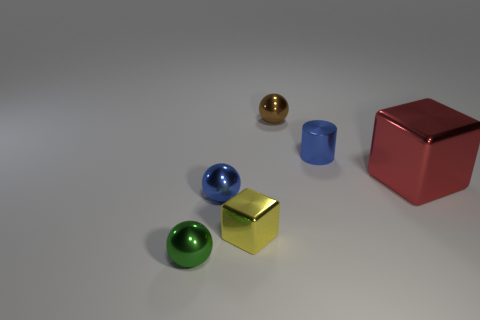Is there anything else that is the same size as the red block?
Offer a very short reply. No. There is a small green thing that is the same shape as the tiny brown object; what material is it?
Provide a succinct answer. Metal. What number of things are green things or gray cylinders?
Your answer should be compact. 1. What number of brown things are the same shape as the green thing?
Offer a terse response. 1. Is the material of the big red object the same as the blue thing that is behind the red metal block?
Offer a terse response. Yes. What size is the red cube that is made of the same material as the tiny yellow object?
Provide a succinct answer. Large. There is a blue cylinder right of the brown ball; what size is it?
Your answer should be very brief. Small. What number of green metal objects have the same size as the brown shiny thing?
Give a very brief answer. 1. Are there any tiny metal spheres that have the same color as the tiny cylinder?
Ensure brevity in your answer.  Yes. There is a metal block that is the same size as the shiny cylinder; what is its color?
Offer a very short reply. Yellow. 